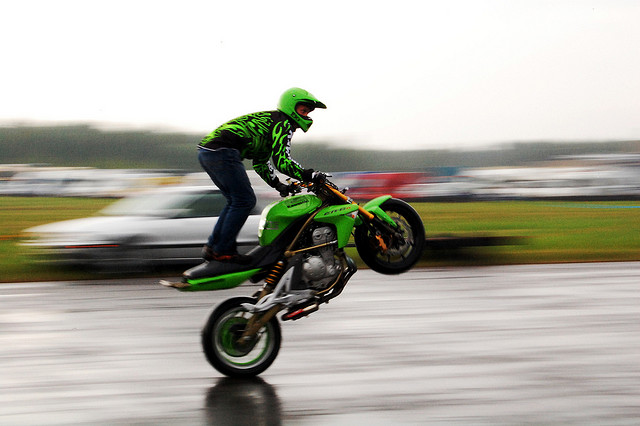What is the motion effect used in the photograph? The photograph employs a motion blur effect to convey speed, which is achieved by using a slower shutter speed while tracking the motorcycle's movement. This technique keeps the motorcycle relatively sharp while the background is blurred, giving a strong sense of motion. 